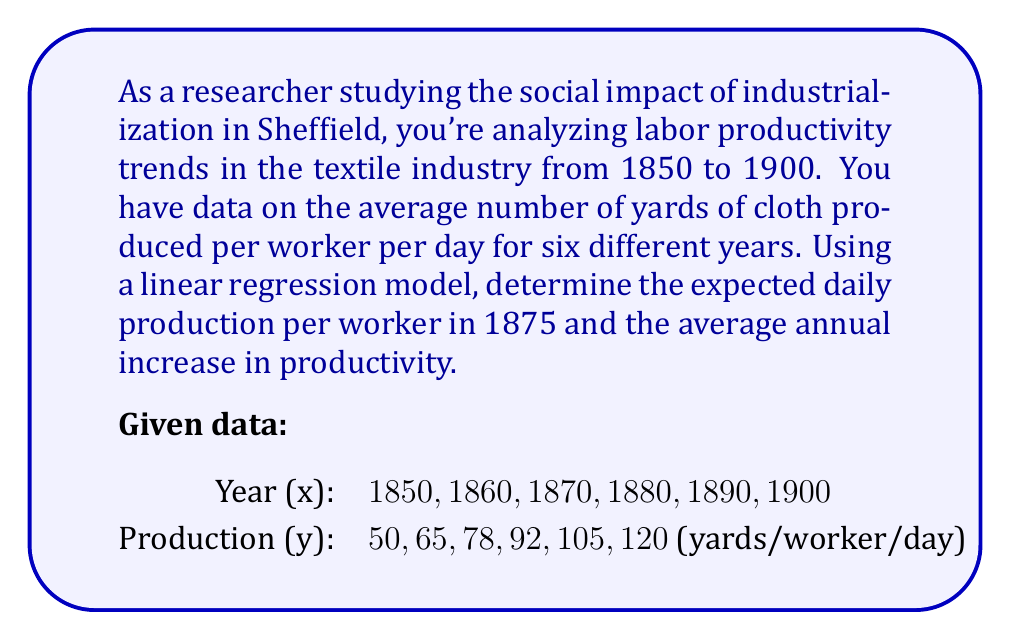Solve this math problem. To solve this problem, we'll use the linear regression model $y = mx + b$, where $m$ is the slope and $b$ is the y-intercept.

Step 1: Calculate the means of x and y.
$\bar{x} = \frac{1850 + 1860 + 1870 + 1880 + 1890 + 1900}{6} = 1875$
$\bar{y} = \frac{50 + 65 + 78 + 92 + 105 + 120}{6} = 85$

Step 2: Calculate the slope (m) using the formula:
$m = \frac{\sum(x_i - \bar{x})(y_i - \bar{y})}{\sum(x_i - \bar{x})^2}$

$\sum(x_i - \bar{x})(y_i - \bar{y}) = (-25)(-35) + (-15)(-20) + (-5)(-7) + (5)(7) + (15)(20) + (25)(35) = 3500$
$\sum(x_i - \bar{x})^2 = (-25)^2 + (-15)^2 + (-5)^2 + (5)^2 + (15)^2 + (25)^2 = 2500$

$m = \frac{3500}{2500} = 1.4$

Step 3: Calculate the y-intercept (b) using $b = \bar{y} - m\bar{x}$
$b = 85 - 1.4(1875) = -2540$

Step 4: Write the linear regression equation
$y = 1.4x - 2540$

Step 5: Calculate the expected daily production for 1875
$y = 1.4(1875) - 2540 = 85$ yards/worker/day

Step 6: Interpret the slope as the average annual increase in productivity
The slope (1.4) represents an increase of 1.4 yards per worker per day each year.
Answer: 85 yards/worker/day in 1875; 1.4 yards/worker/day annual increase 